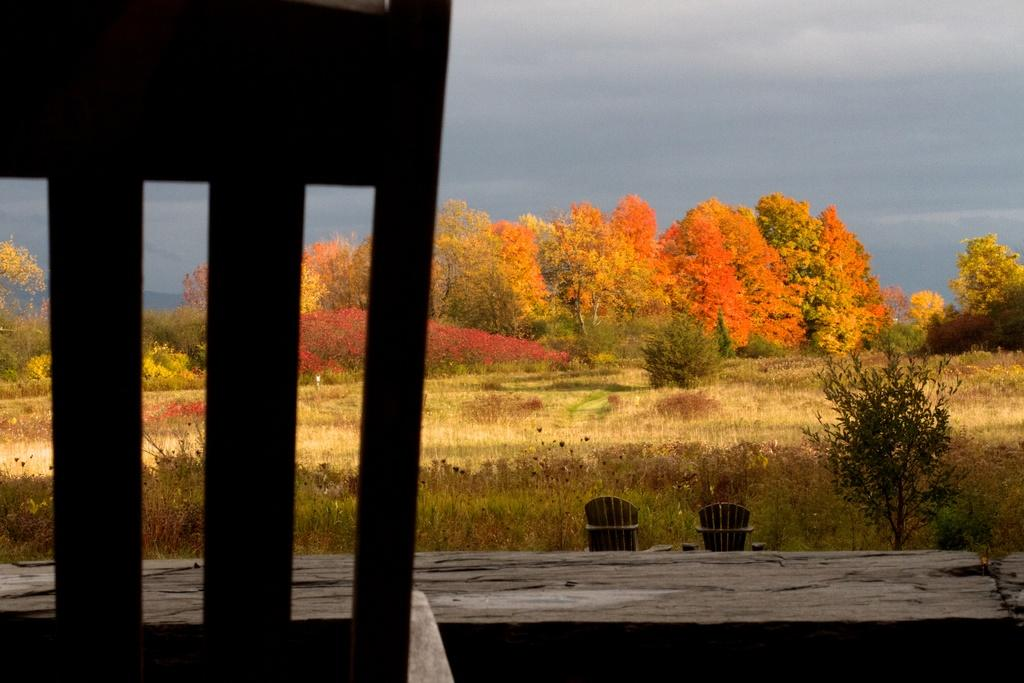What type of furniture is present in the image? There is a chair in the image. What can be seen in the background of the image? There is grass, trees, and the sky visible in the background of the image. What type of bone is visible in the image? There is no bone present in the image. Who is the manager in the image? There is no manager present in the image. 